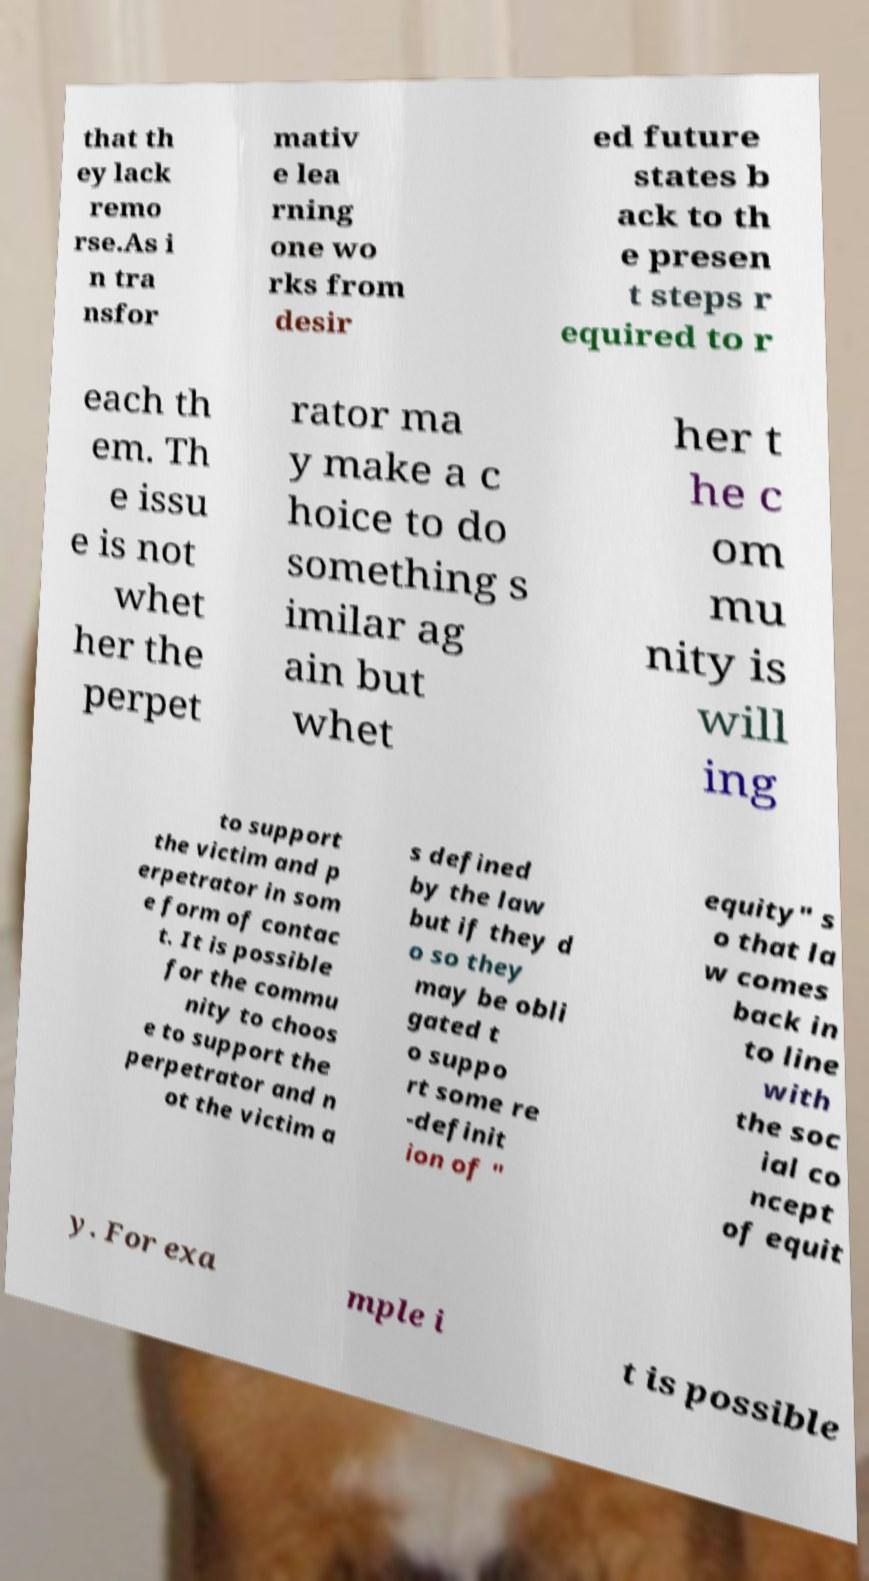Can you accurately transcribe the text from the provided image for me? that th ey lack remo rse.As i n tra nsfor mativ e lea rning one wo rks from desir ed future states b ack to th e presen t steps r equired to r each th em. Th e issu e is not whet her the perpet rator ma y make a c hoice to do something s imilar ag ain but whet her t he c om mu nity is will ing to support the victim and p erpetrator in som e form of contac t. It is possible for the commu nity to choos e to support the perpetrator and n ot the victim a s defined by the law but if they d o so they may be obli gated t o suppo rt some re -definit ion of " equity" s o that la w comes back in to line with the soc ial co ncept of equit y. For exa mple i t is possible 